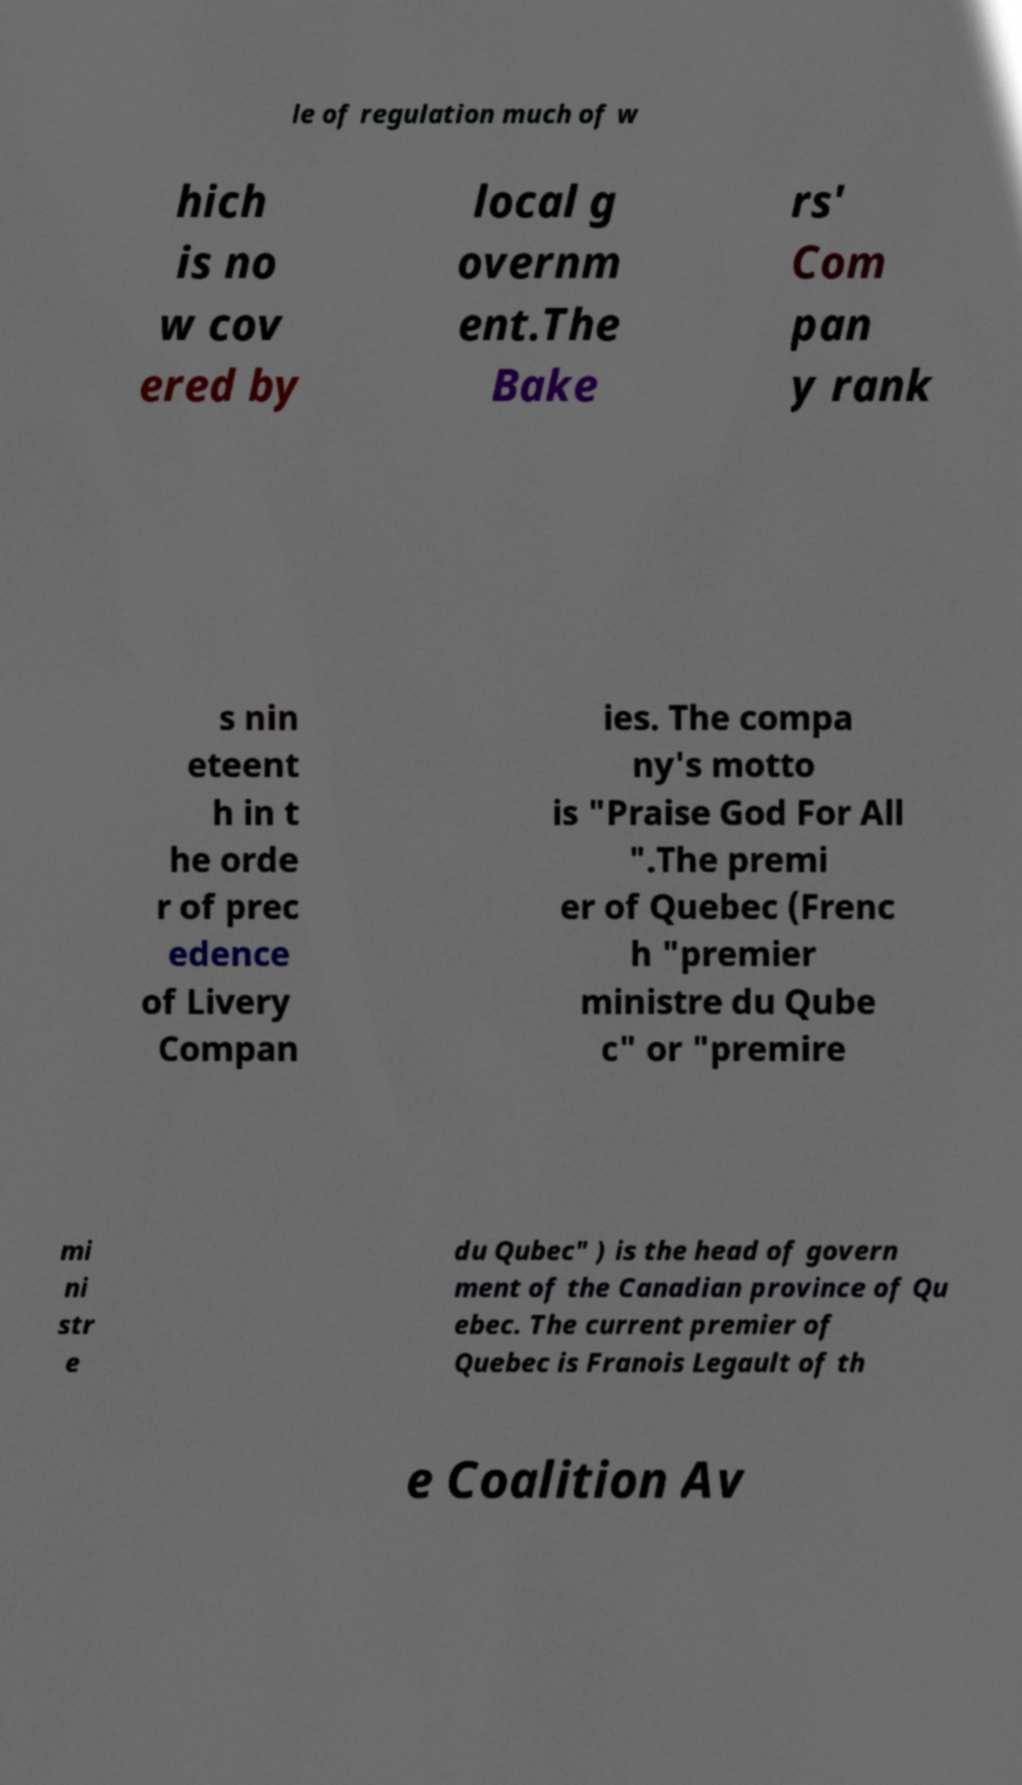Could you assist in decoding the text presented in this image and type it out clearly? le of regulation much of w hich is no w cov ered by local g overnm ent.The Bake rs' Com pan y rank s nin eteent h in t he orde r of prec edence of Livery Compan ies. The compa ny's motto is "Praise God For All ".The premi er of Quebec (Frenc h "premier ministre du Qube c" or "premire mi ni str e du Qubec" ) is the head of govern ment of the Canadian province of Qu ebec. The current premier of Quebec is Franois Legault of th e Coalition Av 